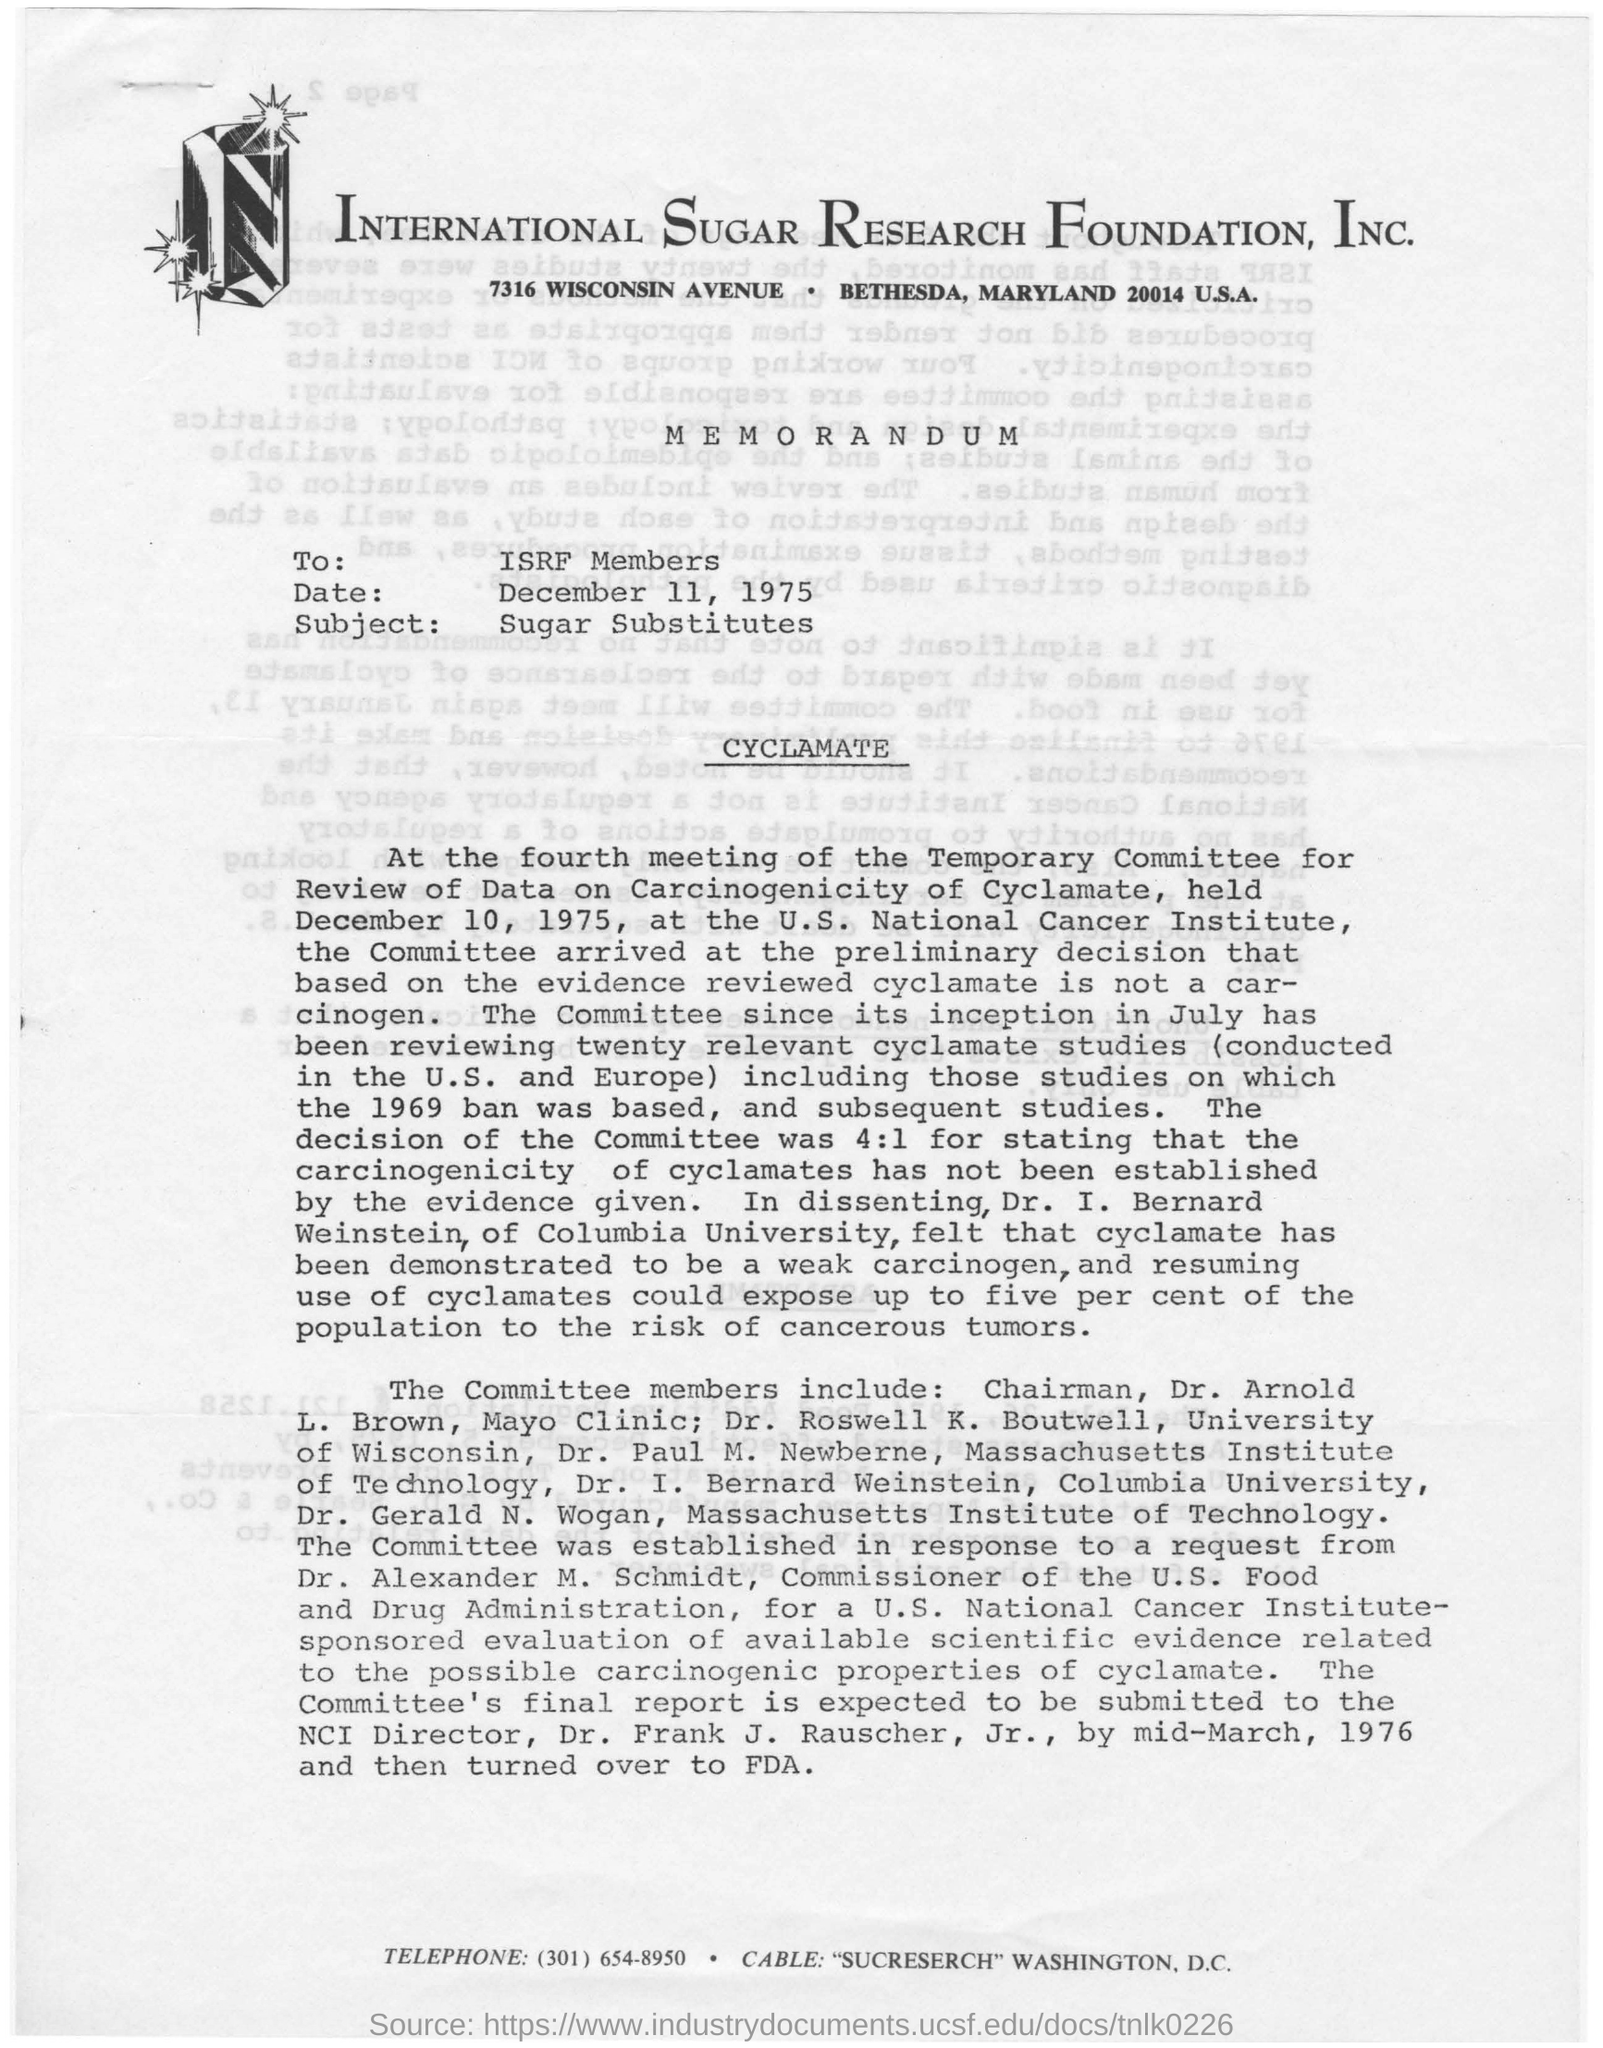What is the name of the foundation mentioned ?
Ensure brevity in your answer.  International sugar research foundation. What is the name of the avenue mentioned ?
Your response must be concise. Wisconsin avenue. To whom the memorandum was written ?
Your answer should be compact. Isrf members. What is the date mentioned in the given page ?
Your answer should be compact. December 11, 1975. What is the subject mentioned ?
Provide a short and direct response. Sugar substitutes. 